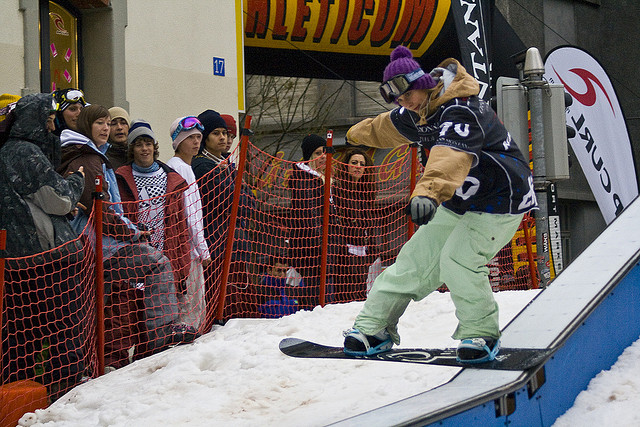Identify the text displayed in this image. 17 